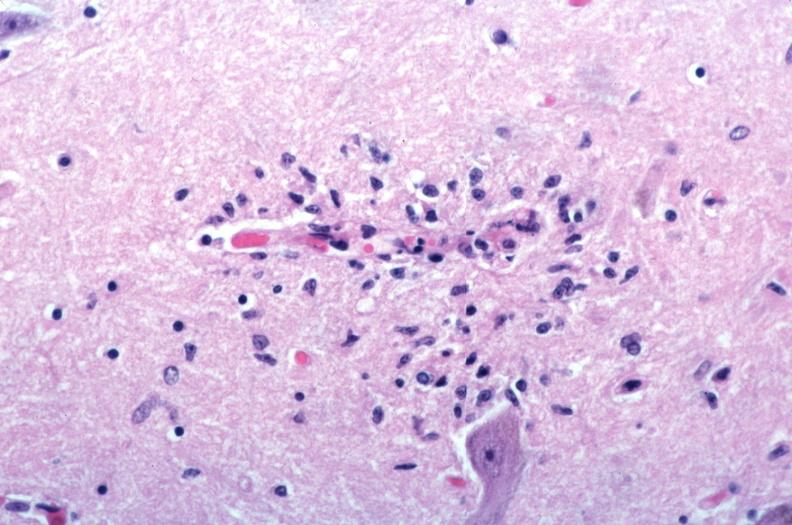does fibrinous peritonitis show brain?
Answer the question using a single word or phrase. No 